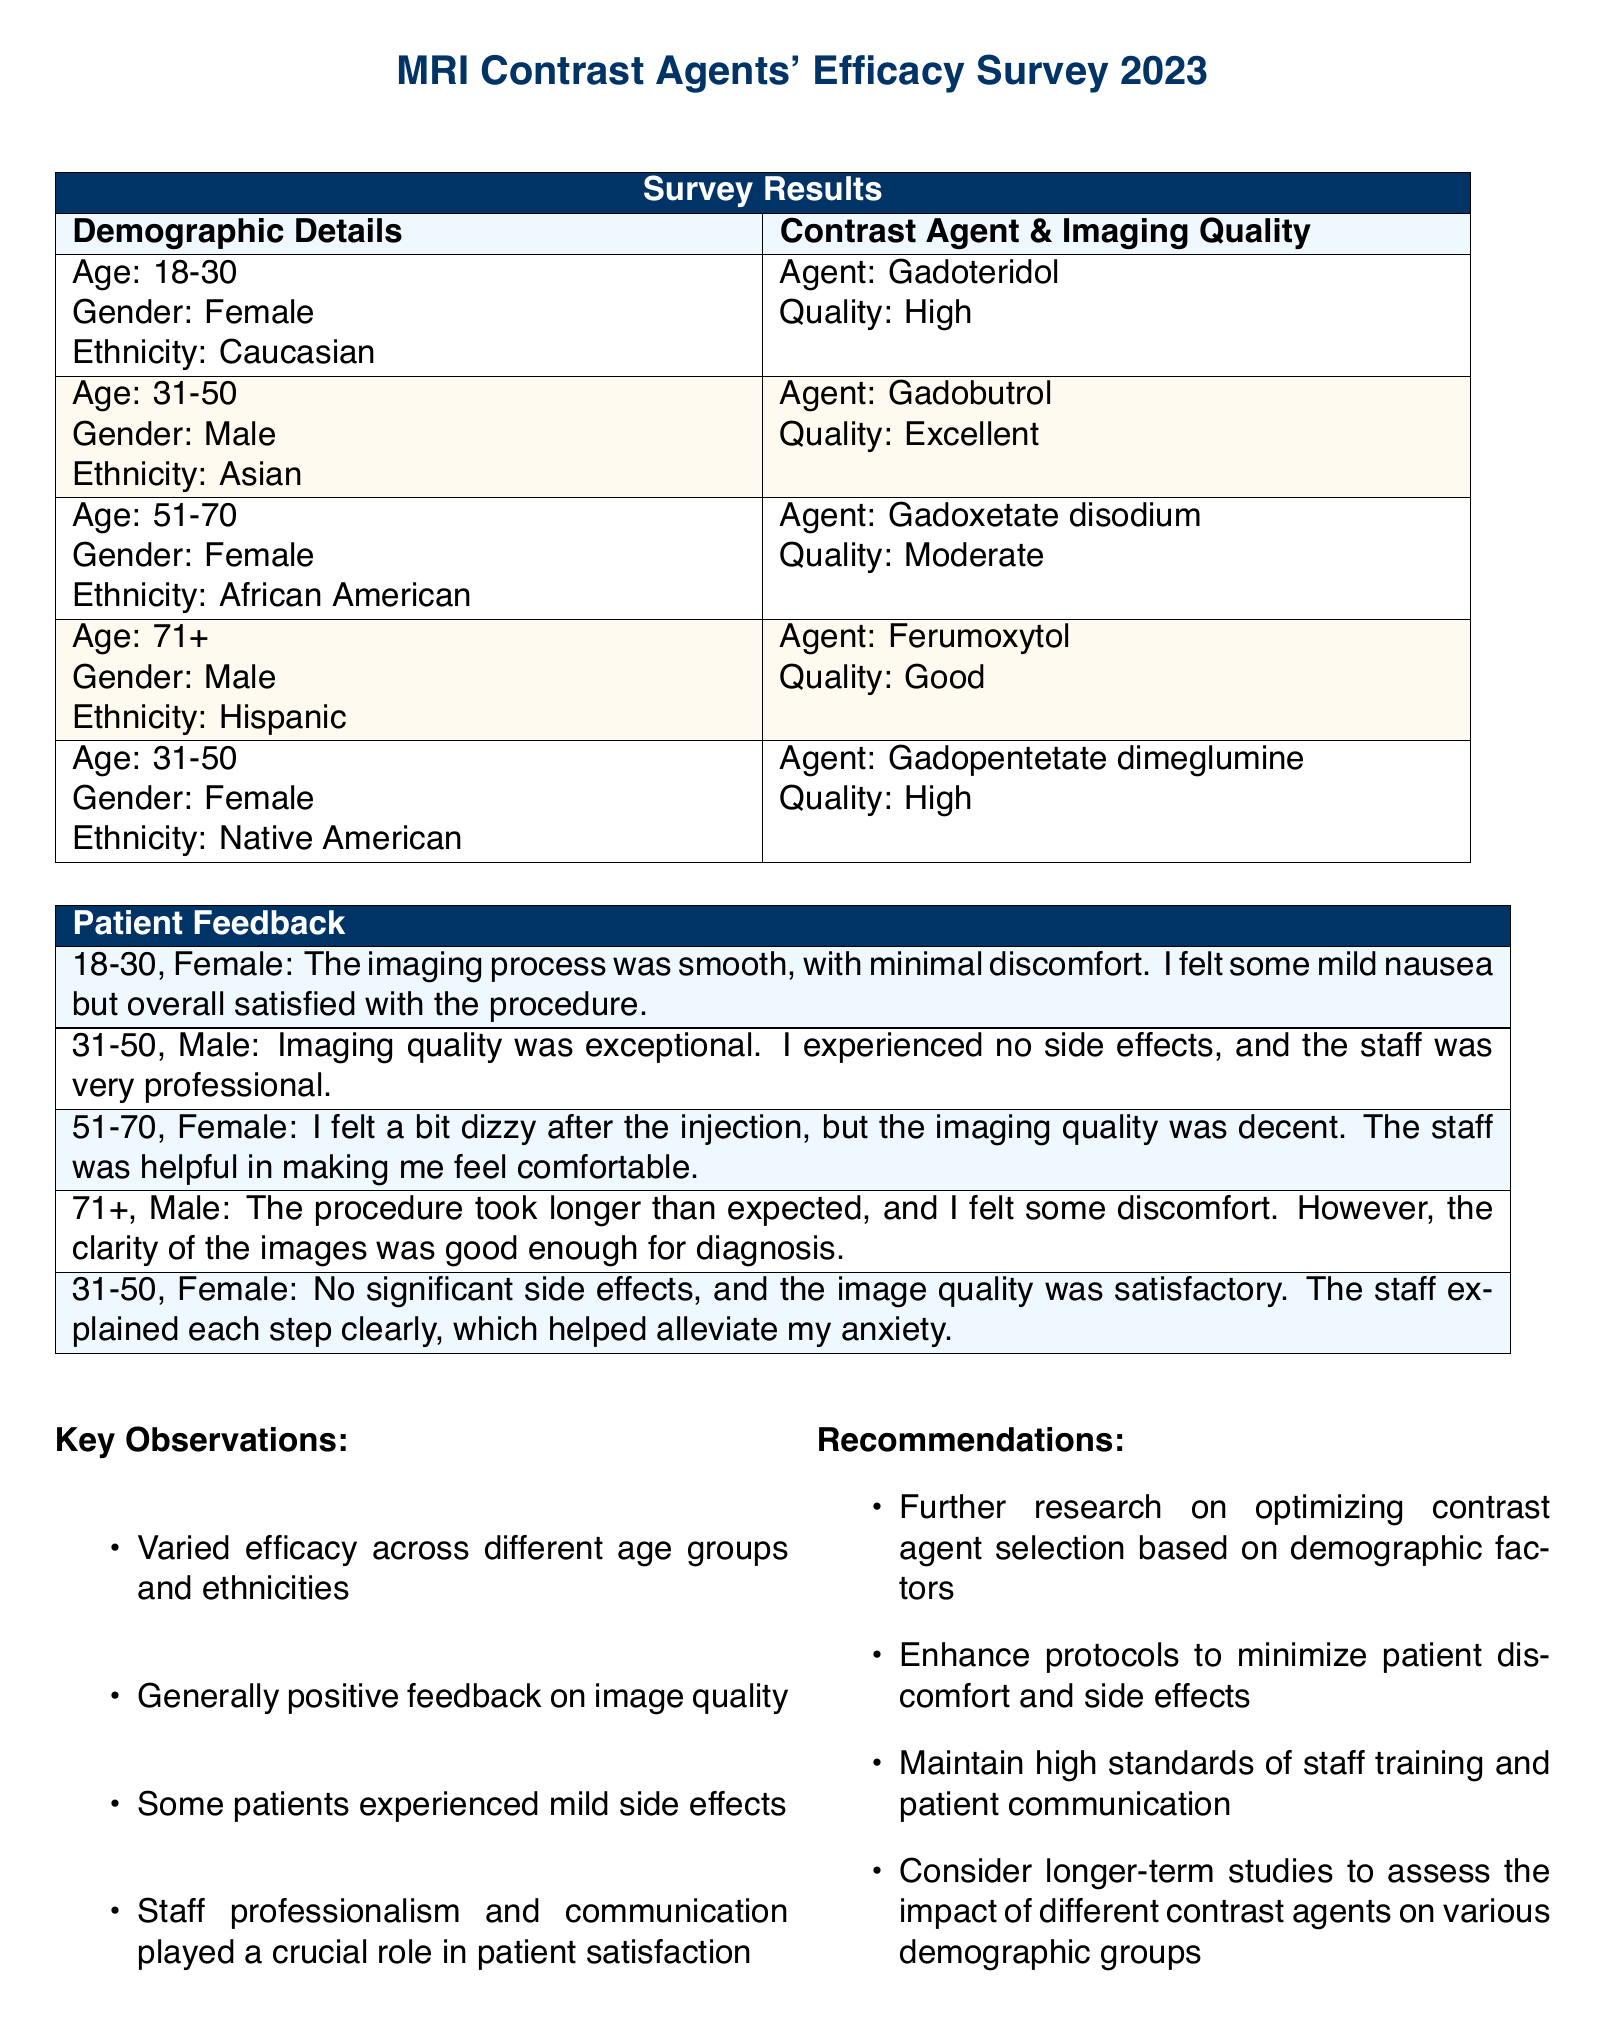what is the age range of the first demographic group? The first demographic group in the survey consists of individuals aged 18-30.
Answer: 18-30 which contrast agent was administered to the demographic group aged 31-50, Male? The contrast agent administered to the demographic group aged 31-50, Male, was Gadobutrol.
Answer: Gadobutrol what quality of imaging was reported for the Gadoxetate disodium contrast agent? The imaging quality reported for the Gadoxetate disodium contrast agent was moderate.
Answer: Moderate how many demographic groups were surveyed? The survey contains details for five demographic groups.
Answer: Five what feedback was given by the female participant aged 51-70? The female participant aged 51-70 felt a bit dizzy after the injection, but noted that the imaging quality was decent.
Answer: A bit dizzy, decent which demographic group reported the best imaging quality? The demographic group aged 31-50, Male, reported the best imaging quality.
Answer: Excellent what key observation was made regarding patient feedback? A key observation made regarding patient feedback was that some patients experienced mild side effects.
Answer: Mild side effects what is one recommendation made in the document? One recommendation made in the document is to enhance protocols to minimize patient discomfort and side effects.
Answer: Enhance protocols 